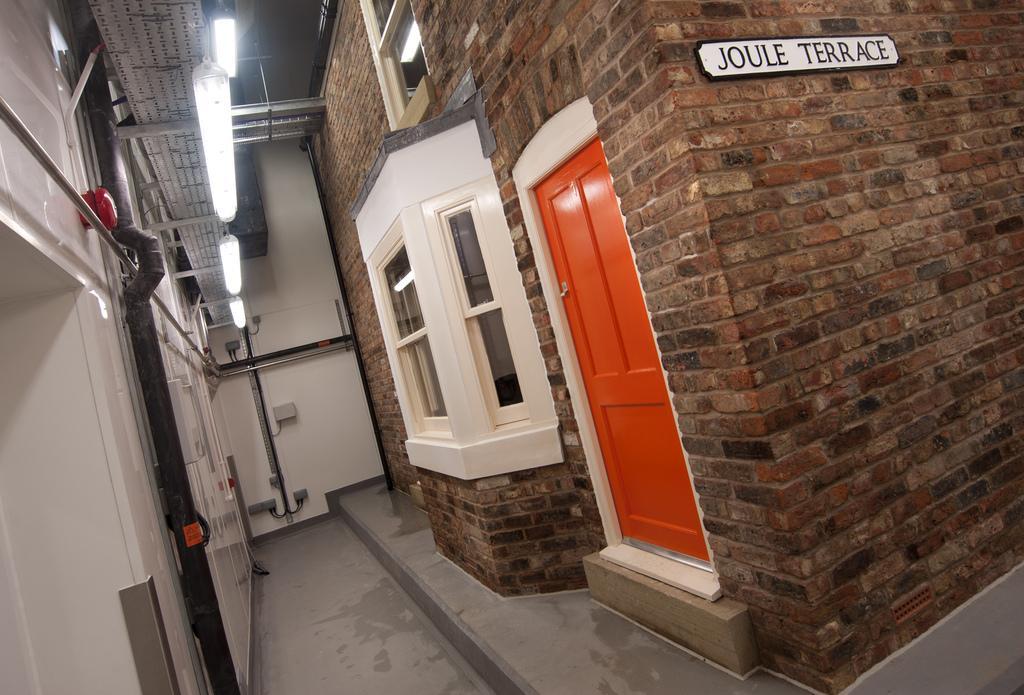Describe this image in one or two sentences. In the image we can see the brick wall, door and the windows. Here we can see the floor, lights, board and text on the board. 